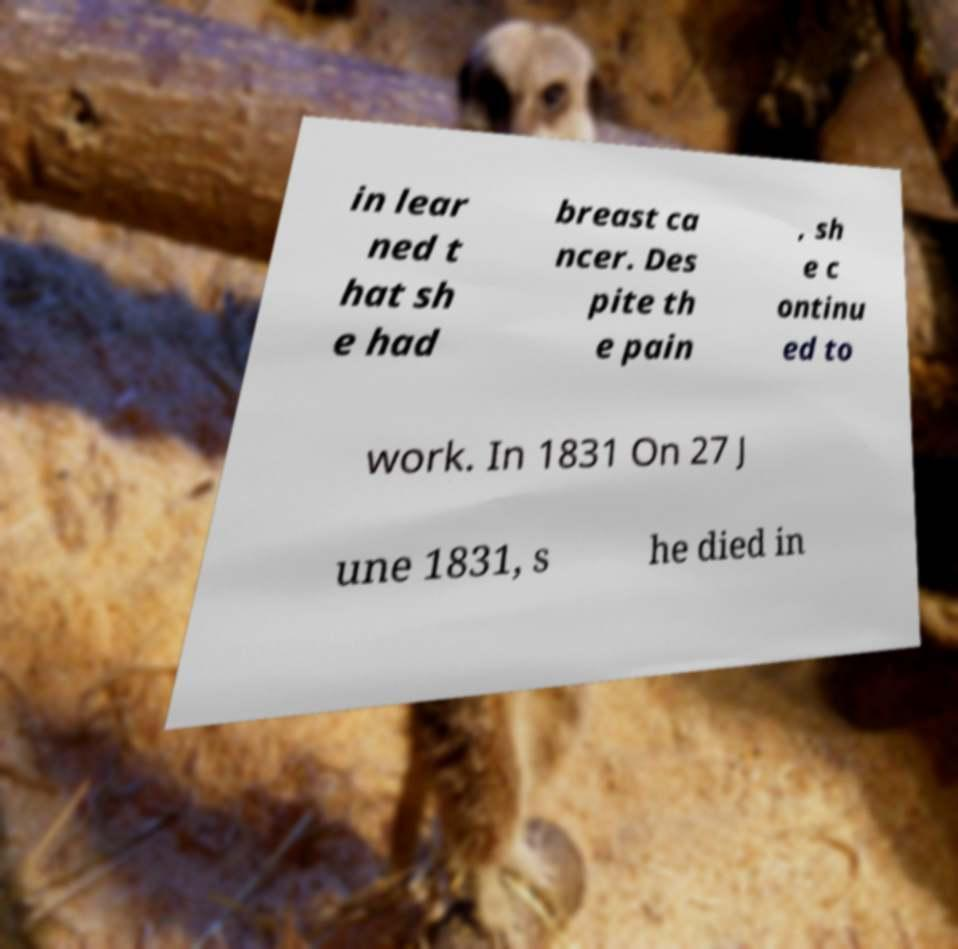What messages or text are displayed in this image? I need them in a readable, typed format. in lear ned t hat sh e had breast ca ncer. Des pite th e pain , sh e c ontinu ed to work. In 1831 On 27 J une 1831, s he died in 